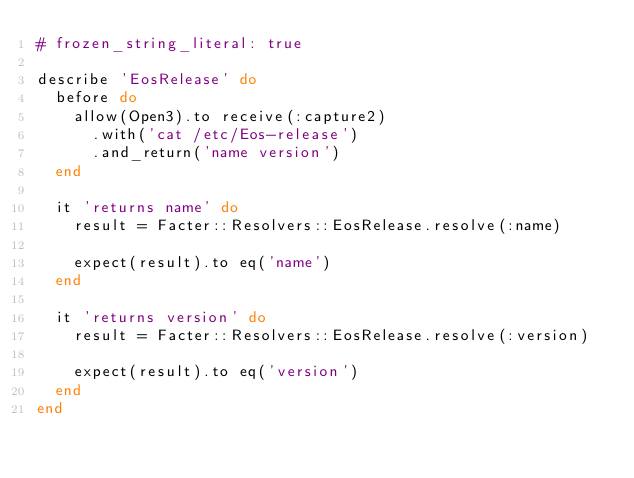<code> <loc_0><loc_0><loc_500><loc_500><_Ruby_># frozen_string_literal: true

describe 'EosRelease' do
  before do
    allow(Open3).to receive(:capture2)
      .with('cat /etc/Eos-release')
      .and_return('name version')
  end

  it 'returns name' do
    result = Facter::Resolvers::EosRelease.resolve(:name)

    expect(result).to eq('name')
  end

  it 'returns version' do
    result = Facter::Resolvers::EosRelease.resolve(:version)

    expect(result).to eq('version')
  end
end
</code> 